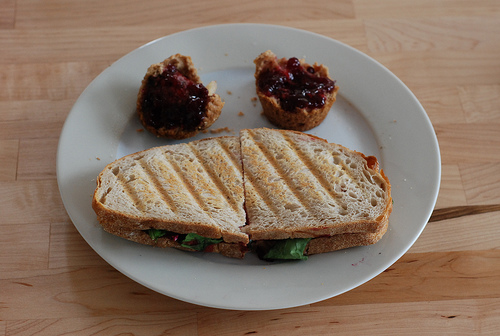What type of bread is used for the sandwich? The bread in the sandwich looks like it could be a whole grain or multigrain bread, as indicated by the visible seeds and grains on its crust. 